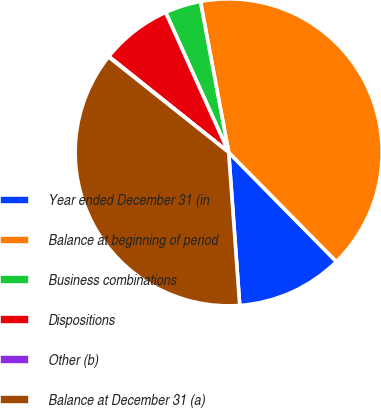Convert chart. <chart><loc_0><loc_0><loc_500><loc_500><pie_chart><fcel>Year ended December 31 (in<fcel>Balance at beginning of period<fcel>Business combinations<fcel>Dispositions<fcel>Other (b)<fcel>Balance at December 31 (a)<nl><fcel>11.24%<fcel>40.56%<fcel>3.79%<fcel>7.52%<fcel>0.06%<fcel>36.83%<nl></chart> 